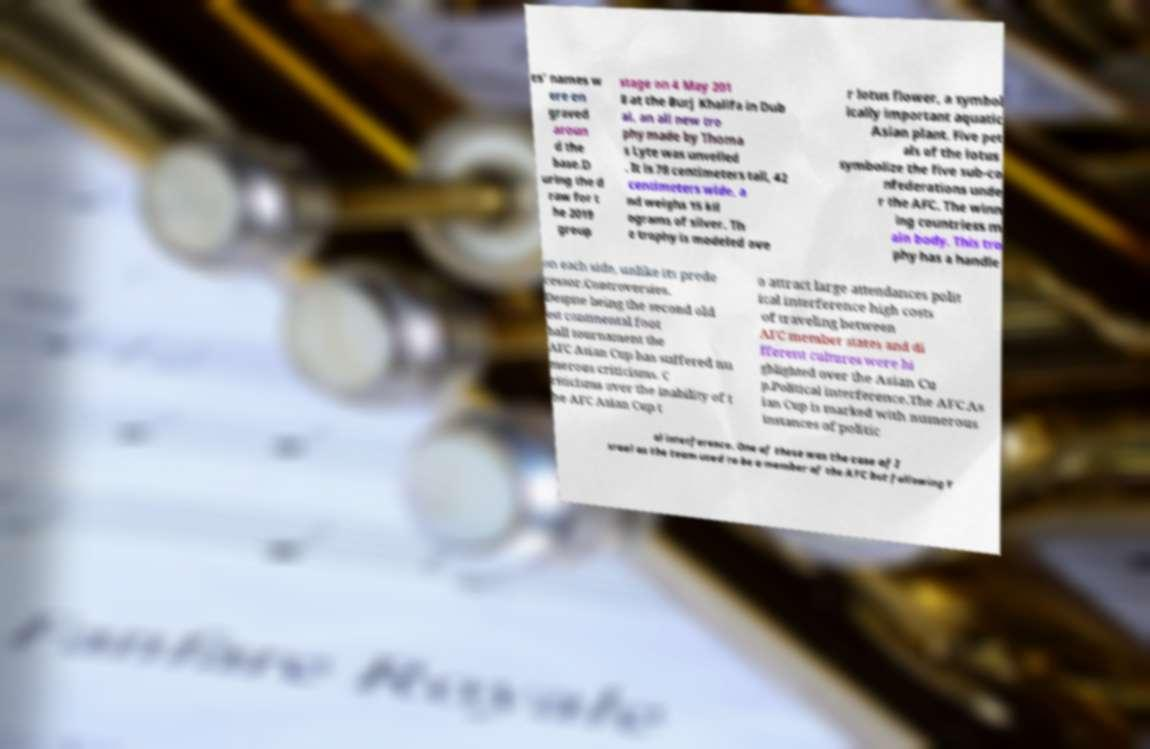What messages or text are displayed in this image? I need them in a readable, typed format. es' names w ere en graved aroun d the base.D uring the d raw for t he 2019 group stage on 4 May 201 8 at the Burj Khalifa in Dub ai, an all new tro phy made by Thoma s Lyte was unveiled . It is 78 centimeters tall, 42 centimeters wide, a nd weighs 15 kil ograms of silver. Th e trophy is modeled ove r lotus flower, a symbol ically important aquatic Asian plant. Five pet als of the lotus symbolize the five sub-co nfederations unde r the AFC. The winn ing countriess m ain body. This tro phy has a handle on each side, unlike its prede cessor.Controversies. Despite being the second old est continental foot ball tournament the AFC Asian Cup has suffered nu merous criticisms. C riticisms over the inability of t he AFC Asian Cup t o attract large attendances polit ical interference high costs of traveling between AFC member states and di fferent cultures were hi ghlighted over the Asian Cu p.Political interference.The AFC As ian Cup is marked with numerous instances of politic al interference. One of these was the case of I srael as the team used to be a member of the AFC but following Y 